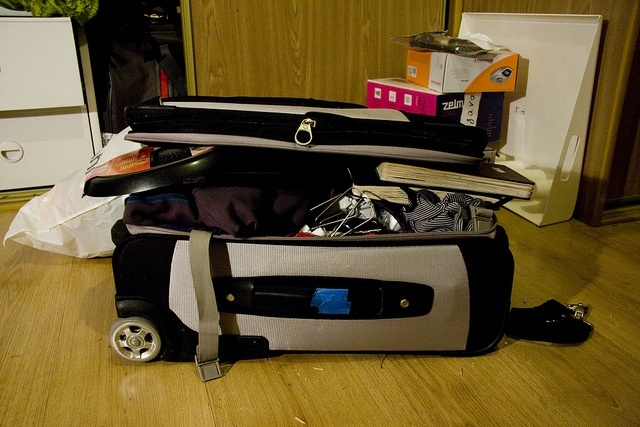Describe the objects in this image and their specific colors. I can see suitcase in darkgreen, black, olive, gray, and darkgray tones, book in darkgreen, black, tan, and olive tones, and book in darkgreen, tan, black, and olive tones in this image. 